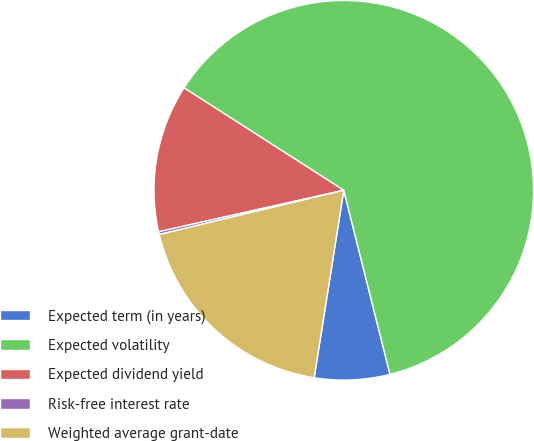<chart> <loc_0><loc_0><loc_500><loc_500><pie_chart><fcel>Expected term (in years)<fcel>Expected volatility<fcel>Expected dividend yield<fcel>Risk-free interest rate<fcel>Weighted average grant-date<nl><fcel>6.41%<fcel>62.01%<fcel>12.58%<fcel>0.24%<fcel>18.76%<nl></chart> 